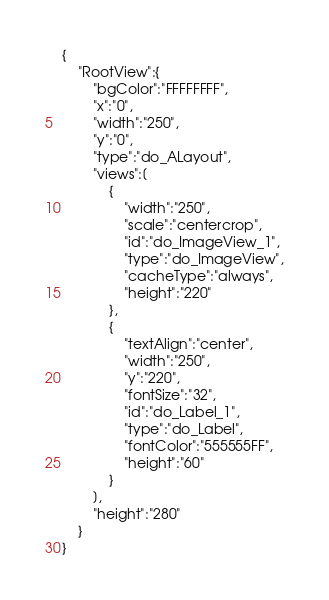Convert code to text. <code><loc_0><loc_0><loc_500><loc_500><_XML_>{
	"RootView":{
		"bgColor":"FFFFFFFF",
		"x":"0",
		"width":"250",
		"y":"0",
		"type":"do_ALayout",
		"views":[
			{
				"width":"250",
				"scale":"centercrop",
				"id":"do_ImageView_1",
				"type":"do_ImageView",
				"cacheType":"always",
				"height":"220"
			},
			{
				"textAlign":"center",
				"width":"250",
				"y":"220",
				"fontSize":"32",
				"id":"do_Label_1",
				"type":"do_Label",
				"fontColor":"555555FF",
				"height":"60"
			}
		],
		"height":"280"
	}
}</code> 